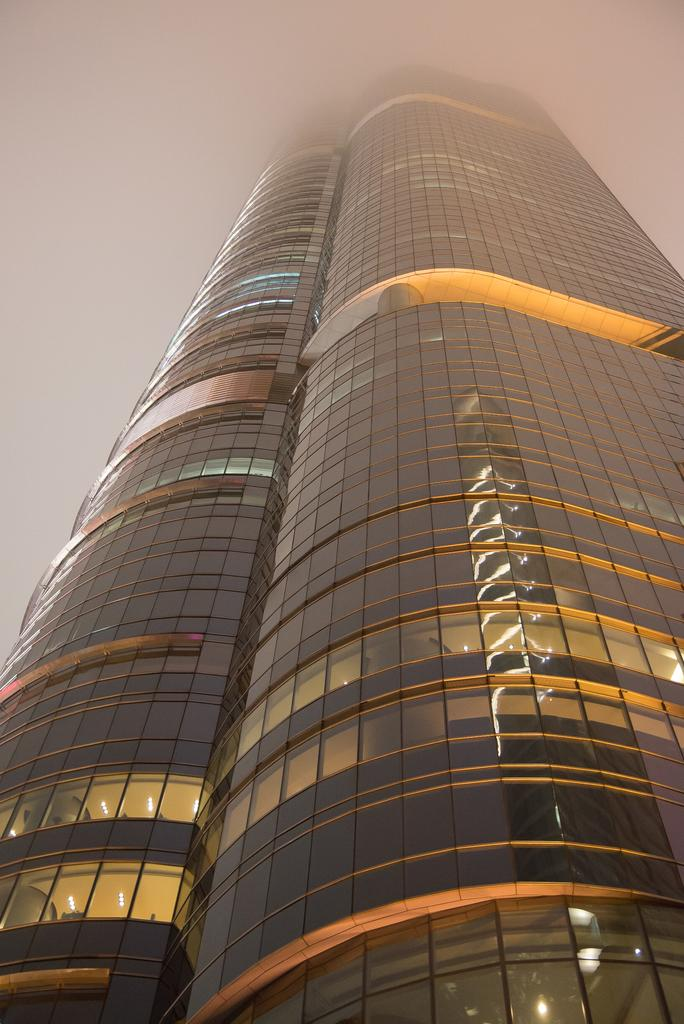Where was the image taken? The image was clicked outside. What is the main subject in the center of the image? There is a skyscraper in the center of the image. What can be seen in the background of the image? The sky is visible in the background of the image. What type of club can be seen in the image? There is no club present in the image; it features a skyscraper and the sky. What mineral is visible in the image? There is no mineral, such as quartz, present in the image. 